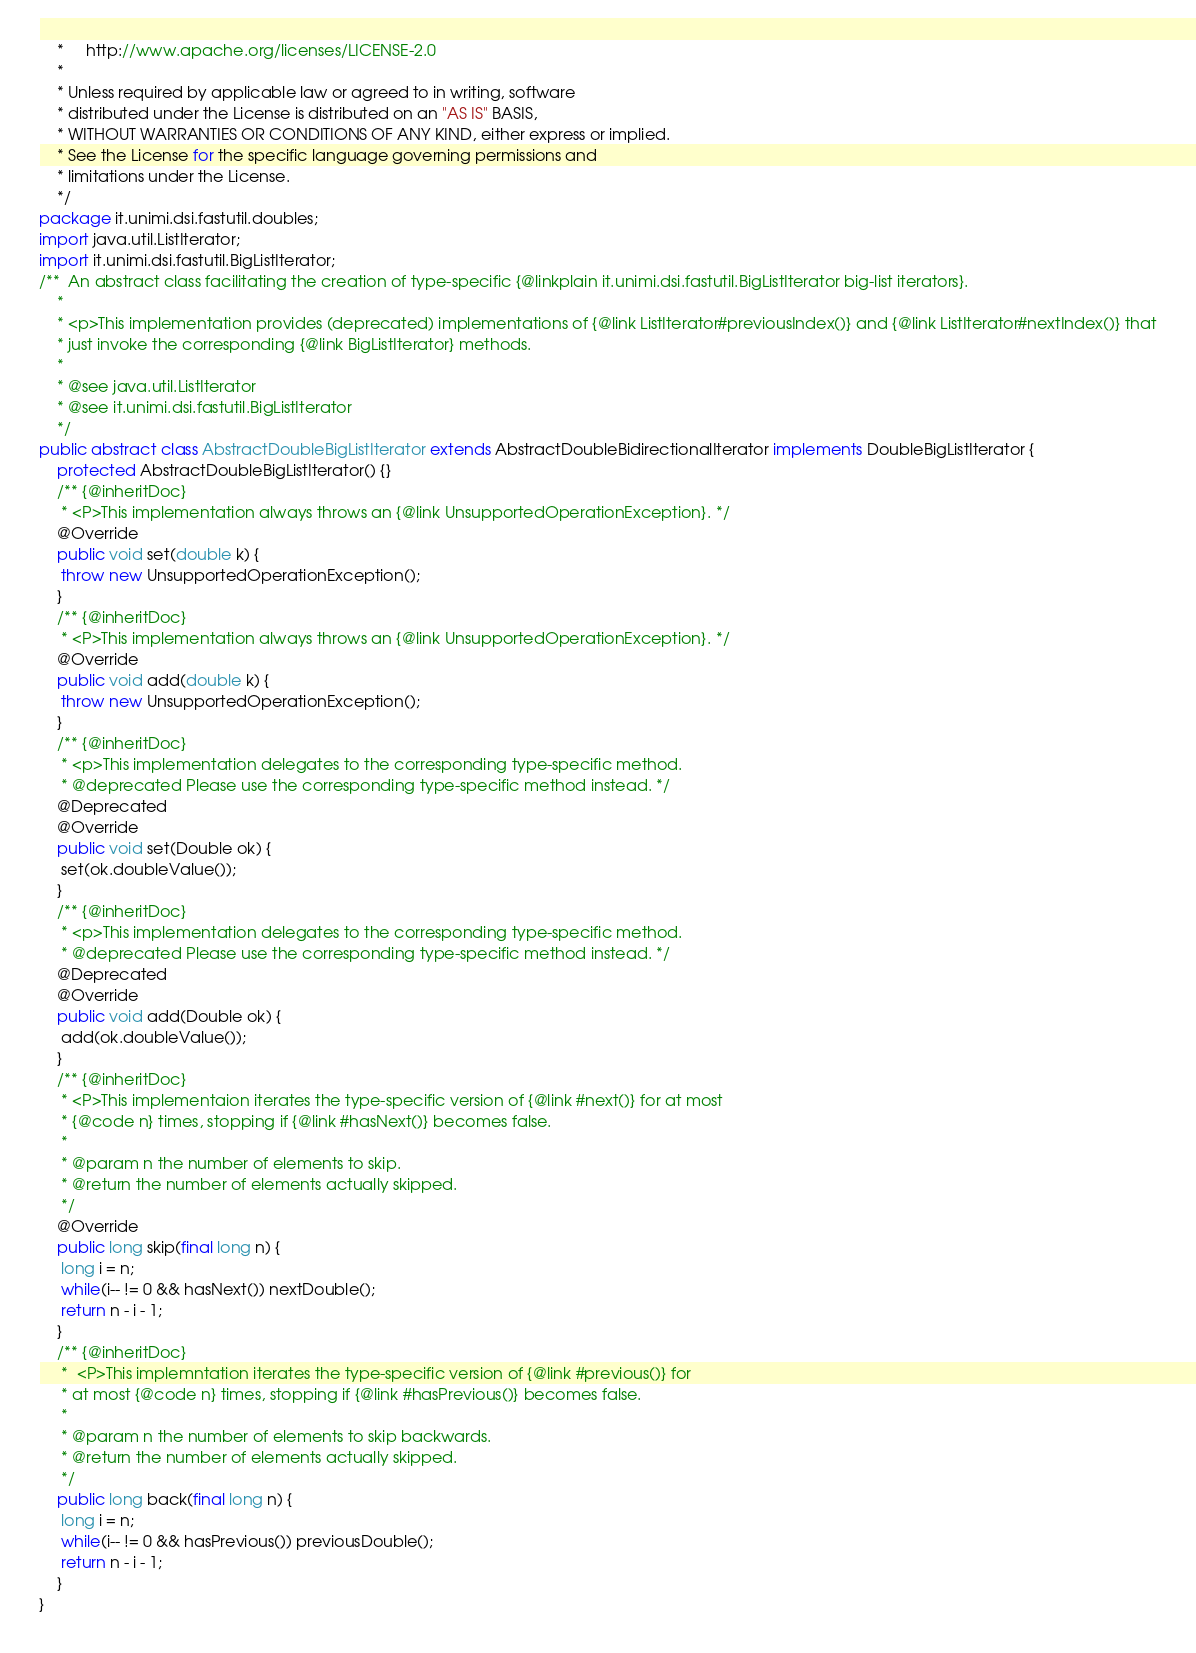<code> <loc_0><loc_0><loc_500><loc_500><_Java_>	*     http://www.apache.org/licenses/LICENSE-2.0
	*
	* Unless required by applicable law or agreed to in writing, software
	* distributed under the License is distributed on an "AS IS" BASIS,
	* WITHOUT WARRANTIES OR CONDITIONS OF ANY KIND, either express or implied.
	* See the License for the specific language governing permissions and
	* limitations under the License.
	*/
package it.unimi.dsi.fastutil.doubles;
import java.util.ListIterator;
import it.unimi.dsi.fastutil.BigListIterator;
/**  An abstract class facilitating the creation of type-specific {@linkplain it.unimi.dsi.fastutil.BigListIterator big-list iterators}.
	*
	* <p>This implementation provides (deprecated) implementations of {@link ListIterator#previousIndex()} and {@link ListIterator#nextIndex()} that
	* just invoke the corresponding {@link BigListIterator} methods.
	*
	* @see java.util.ListIterator
	* @see it.unimi.dsi.fastutil.BigListIterator
	*/
public abstract class AbstractDoubleBigListIterator extends AbstractDoubleBidirectionalIterator implements DoubleBigListIterator {
	protected AbstractDoubleBigListIterator() {}
	/** {@inheritDoc}
	 * <P>This implementation always throws an {@link UnsupportedOperationException}. */
	@Override
	public void set(double k) {
	 throw new UnsupportedOperationException();
	}
	/** {@inheritDoc}
	 * <P>This implementation always throws an {@link UnsupportedOperationException}. */
	@Override
	public void add(double k) {
	 throw new UnsupportedOperationException();
	}
	/** {@inheritDoc}
	 * <p>This implementation delegates to the corresponding type-specific method.
	 * @deprecated Please use the corresponding type-specific method instead. */
	@Deprecated
	@Override
	public void set(Double ok) {
	 set(ok.doubleValue());
	}
	/** {@inheritDoc}
	 * <p>This implementation delegates to the corresponding type-specific method.
	 * @deprecated Please use the corresponding type-specific method instead. */
	@Deprecated
	@Override
	public void add(Double ok) {
	 add(ok.doubleValue());
	}
	/** {@inheritDoc}
	 * <P>This implementaion iterates the type-specific version of {@link #next()} for at most
	 * {@code n} times, stopping if {@link #hasNext()} becomes false.
	 *
	 * @param n the number of elements to skip.
	 * @return the number of elements actually skipped.
	 */
	@Override
	public long skip(final long n) {
	 long i = n;
	 while(i-- != 0 && hasNext()) nextDouble();
	 return n - i - 1;
	}
	/** {@inheritDoc}
	 *  <P>This implemntation iterates the type-specific version of {@link #previous()} for
	 * at most {@code n} times, stopping if {@link #hasPrevious()} becomes false.
	 *
	 * @param n the number of elements to skip backwards.
	 * @return the number of elements actually skipped.
	 */
	public long back(final long n) {
	 long i = n;
	 while(i-- != 0 && hasPrevious()) previousDouble();
	 return n - i - 1;
	}
}
</code> 